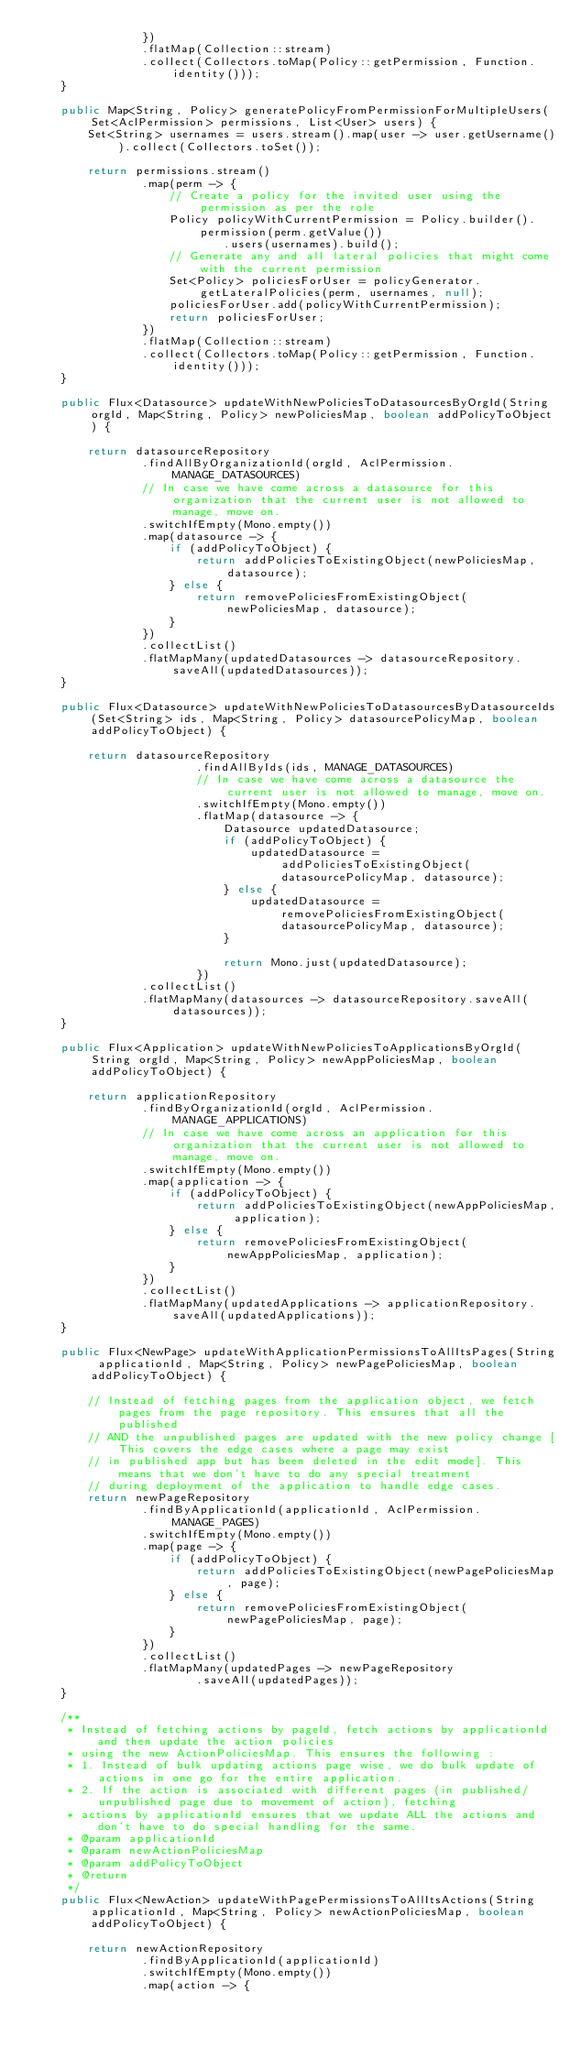Convert code to text. <code><loc_0><loc_0><loc_500><loc_500><_Java_>                })
                .flatMap(Collection::stream)
                .collect(Collectors.toMap(Policy::getPermission, Function.identity()));
    }

    public Map<String, Policy> generatePolicyFromPermissionForMultipleUsers(Set<AclPermission> permissions, List<User> users) {
        Set<String> usernames = users.stream().map(user -> user.getUsername()).collect(Collectors.toSet());

        return permissions.stream()
                .map(perm -> {
                    // Create a policy for the invited user using the permission as per the role
                    Policy policyWithCurrentPermission = Policy.builder().permission(perm.getValue())
                            .users(usernames).build();
                    // Generate any and all lateral policies that might come with the current permission
                    Set<Policy> policiesForUser = policyGenerator.getLateralPolicies(perm, usernames, null);
                    policiesForUser.add(policyWithCurrentPermission);
                    return policiesForUser;
                })
                .flatMap(Collection::stream)
                .collect(Collectors.toMap(Policy::getPermission, Function.identity()));
    }

    public Flux<Datasource> updateWithNewPoliciesToDatasourcesByOrgId(String orgId, Map<String, Policy> newPoliciesMap, boolean addPolicyToObject) {

        return datasourceRepository
                .findAllByOrganizationId(orgId, AclPermission.MANAGE_DATASOURCES)
                // In case we have come across a datasource for this organization that the current user is not allowed to manage, move on.
                .switchIfEmpty(Mono.empty())
                .map(datasource -> {
                    if (addPolicyToObject) {
                        return addPoliciesToExistingObject(newPoliciesMap, datasource);
                    } else {
                        return removePoliciesFromExistingObject(newPoliciesMap, datasource);
                    }
                })
                .collectList()
                .flatMapMany(updatedDatasources -> datasourceRepository.saveAll(updatedDatasources));
    }

    public Flux<Datasource> updateWithNewPoliciesToDatasourcesByDatasourceIds(Set<String> ids, Map<String, Policy> datasourcePolicyMap, boolean addPolicyToObject) {

        return datasourceRepository
                        .findAllByIds(ids, MANAGE_DATASOURCES)
                        // In case we have come across a datasource the current user is not allowed to manage, move on.
                        .switchIfEmpty(Mono.empty())
                        .flatMap(datasource -> {
                            Datasource updatedDatasource;
                            if (addPolicyToObject) {
                                updatedDatasource = addPoliciesToExistingObject(datasourcePolicyMap, datasource);
                            } else {
                                updatedDatasource = removePoliciesFromExistingObject(datasourcePolicyMap, datasource);
                            }

                            return Mono.just(updatedDatasource);
                        })
                .collectList()
                .flatMapMany(datasources -> datasourceRepository.saveAll(datasources));
    }

    public Flux<Application> updateWithNewPoliciesToApplicationsByOrgId(String orgId, Map<String, Policy> newAppPoliciesMap, boolean addPolicyToObject) {

        return applicationRepository
                .findByOrganizationId(orgId, AclPermission.MANAGE_APPLICATIONS)
                // In case we have come across an application for this organization that the current user is not allowed to manage, move on.
                .switchIfEmpty(Mono.empty())
                .map(application -> {
                    if (addPolicyToObject) {
                        return addPoliciesToExistingObject(newAppPoliciesMap, application);
                    } else {
                        return removePoliciesFromExistingObject(newAppPoliciesMap, application);
                    }
                })
                .collectList()
                .flatMapMany(updatedApplications -> applicationRepository.saveAll(updatedApplications));
    }

    public Flux<NewPage> updateWithApplicationPermissionsToAllItsPages(String applicationId, Map<String, Policy> newPagePoliciesMap, boolean addPolicyToObject) {

        // Instead of fetching pages from the application object, we fetch pages from the page repository. This ensures that all the published
        // AND the unpublished pages are updated with the new policy change [This covers the edge cases where a page may exist
        // in published app but has been deleted in the edit mode]. This means that we don't have to do any special treatment
        // during deployment of the application to handle edge cases.
        return newPageRepository
                .findByApplicationId(applicationId, AclPermission.MANAGE_PAGES)
                .switchIfEmpty(Mono.empty())
                .map(page -> {
                    if (addPolicyToObject) {
                        return addPoliciesToExistingObject(newPagePoliciesMap, page);
                    } else {
                        return removePoliciesFromExistingObject(newPagePoliciesMap, page);
                    }
                })
                .collectList()
                .flatMapMany(updatedPages -> newPageRepository
                        .saveAll(updatedPages));
    }

    /**
     * Instead of fetching actions by pageId, fetch actions by applicationId and then update the action policies
     * using the new ActionPoliciesMap. This ensures the following :
     * 1. Instead of bulk updating actions page wise, we do bulk update of actions in one go for the entire application.
     * 2. If the action is associated with different pages (in published/unpublished page due to movement of action), fetching
     * actions by applicationId ensures that we update ALL the actions and don't have to do special handling for the same.
     * @param applicationId
     * @param newActionPoliciesMap
     * @param addPolicyToObject
     * @return
     */
    public Flux<NewAction> updateWithPagePermissionsToAllItsActions(String applicationId, Map<String, Policy> newActionPoliciesMap, boolean addPolicyToObject) {

        return newActionRepository
                .findByApplicationId(applicationId)
                .switchIfEmpty(Mono.empty())
                .map(action -> {</code> 